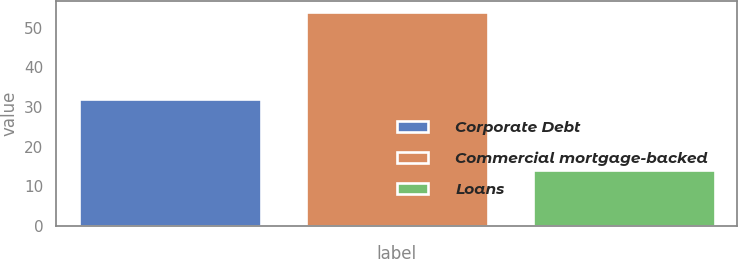Convert chart. <chart><loc_0><loc_0><loc_500><loc_500><bar_chart><fcel>Corporate Debt<fcel>Commercial mortgage-backed<fcel>Loans<nl><fcel>32<fcel>54<fcel>14<nl></chart> 